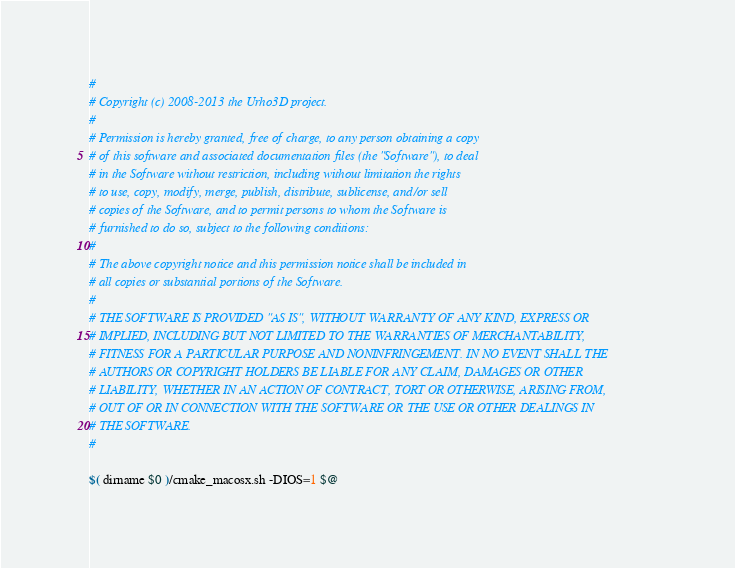<code> <loc_0><loc_0><loc_500><loc_500><_Bash_>#
# Copyright (c) 2008-2013 the Urho3D project.
#
# Permission is hereby granted, free of charge, to any person obtaining a copy
# of this software and associated documentation files (the "Software"), to deal
# in the Software without restriction, including without limitation the rights
# to use, copy, modify, merge, publish, distribute, sublicense, and/or sell
# copies of the Software, and to permit persons to whom the Software is
# furnished to do so, subject to the following conditions:
#
# The above copyright notice and this permission notice shall be included in
# all copies or substantial portions of the Software.
#
# THE SOFTWARE IS PROVIDED "AS IS", WITHOUT WARRANTY OF ANY KIND, EXPRESS OR
# IMPLIED, INCLUDING BUT NOT LIMITED TO THE WARRANTIES OF MERCHANTABILITY,
# FITNESS FOR A PARTICULAR PURPOSE AND NONINFRINGEMENT. IN NO EVENT SHALL THE
# AUTHORS OR COPYRIGHT HOLDERS BE LIABLE FOR ANY CLAIM, DAMAGES OR OTHER
# LIABILITY, WHETHER IN AN ACTION OF CONTRACT, TORT OR OTHERWISE, ARISING FROM,
# OUT OF OR IN CONNECTION WITH THE SOFTWARE OR THE USE OR OTHER DEALINGS IN
# THE SOFTWARE.
#

$( dirname $0 )/cmake_macosx.sh -DIOS=1 $@
</code> 